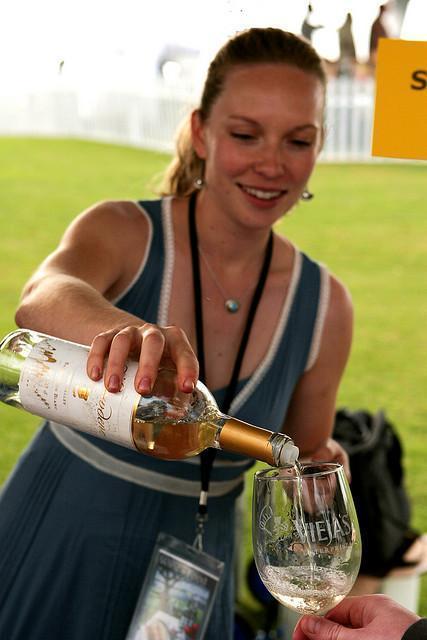How many people are in the photo?
Give a very brief answer. 2. How many cats are in the photo?
Give a very brief answer. 0. 